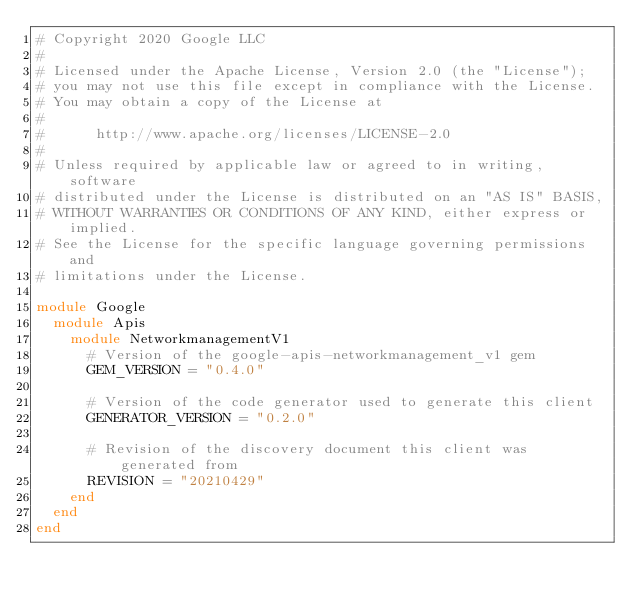Convert code to text. <code><loc_0><loc_0><loc_500><loc_500><_Ruby_># Copyright 2020 Google LLC
#
# Licensed under the Apache License, Version 2.0 (the "License");
# you may not use this file except in compliance with the License.
# You may obtain a copy of the License at
#
#      http://www.apache.org/licenses/LICENSE-2.0
#
# Unless required by applicable law or agreed to in writing, software
# distributed under the License is distributed on an "AS IS" BASIS,
# WITHOUT WARRANTIES OR CONDITIONS OF ANY KIND, either express or implied.
# See the License for the specific language governing permissions and
# limitations under the License.

module Google
  module Apis
    module NetworkmanagementV1
      # Version of the google-apis-networkmanagement_v1 gem
      GEM_VERSION = "0.4.0"

      # Version of the code generator used to generate this client
      GENERATOR_VERSION = "0.2.0"

      # Revision of the discovery document this client was generated from
      REVISION = "20210429"
    end
  end
end
</code> 